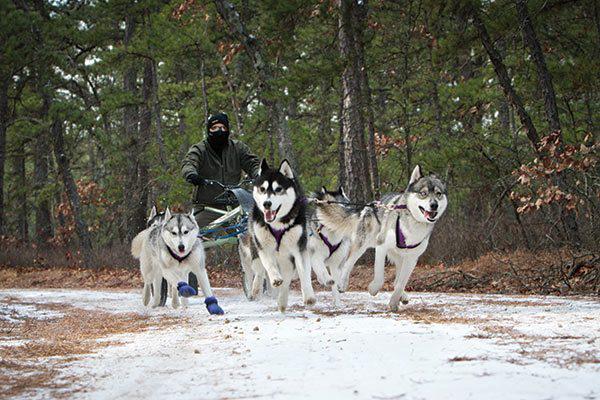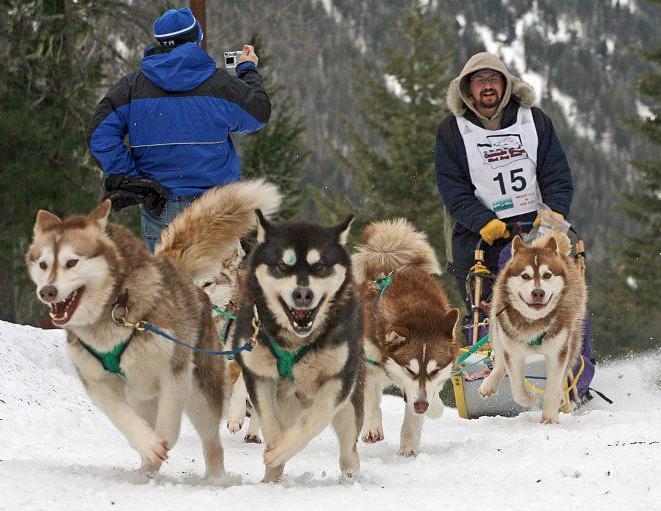The first image is the image on the left, the second image is the image on the right. Given the left and right images, does the statement "All of the dogs are moving forward." hold true? Answer yes or no. Yes. The first image is the image on the left, the second image is the image on the right. For the images displayed, is the sentence "The left image shows a sled dog team heading forward over snow, and the right image shows dogs hitched to a forward-facing wheeled vehicle on a path bare of snow." factually correct? Answer yes or no. No. 